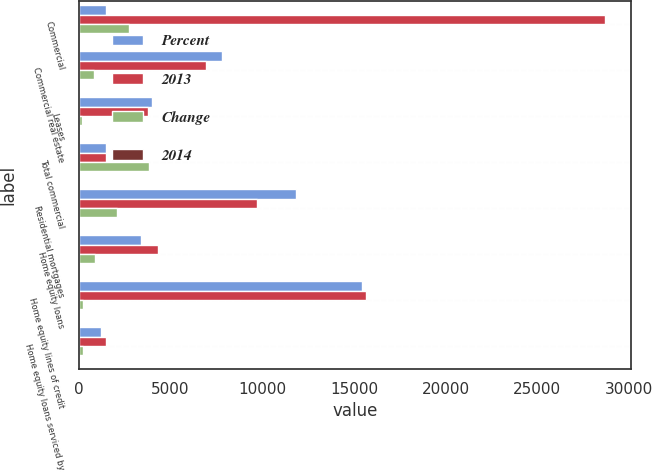Convert chart. <chart><loc_0><loc_0><loc_500><loc_500><stacked_bar_chart><ecel><fcel>Commercial<fcel>Commercial real estate<fcel>Leases<fcel>Total commercial<fcel>Residential mortgages<fcel>Home equity loans<fcel>Home equity lines of credit<fcel>Home equity loans serviced by<nl><fcel>Percent<fcel>1492<fcel>7809<fcel>3986<fcel>1492<fcel>11832<fcel>3424<fcel>15423<fcel>1228<nl><fcel>2013<fcel>28667<fcel>6948<fcel>3780<fcel>1492<fcel>9726<fcel>4301<fcel>15667<fcel>1492<nl><fcel>Change<fcel>2764<fcel>861<fcel>206<fcel>3831<fcel>2106<fcel>877<fcel>244<fcel>264<nl><fcel>2014<fcel>10<fcel>12<fcel>5<fcel>10<fcel>22<fcel>20<fcel>2<fcel>18<nl></chart> 